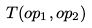<formula> <loc_0><loc_0><loc_500><loc_500>T ( o p _ { 1 } , o p _ { 2 } )</formula> 